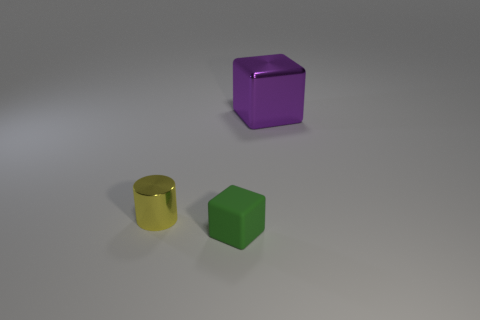There is a small green object that is the same shape as the big purple object; what material is it?
Your response must be concise. Rubber. Are there any other things that are the same size as the green block?
Ensure brevity in your answer.  Yes. Is the number of small yellow matte cylinders greater than the number of matte objects?
Provide a succinct answer. No. There is a thing that is behind the tiny matte thing and on the right side of the small yellow cylinder; what size is it?
Your answer should be very brief. Large. The big shiny object is what shape?
Make the answer very short. Cube. What number of metallic things have the same shape as the small green rubber object?
Your answer should be compact. 1. Is the number of small metal cylinders that are on the right side of the large metallic cube less than the number of shiny things right of the yellow metallic cylinder?
Offer a terse response. Yes. What number of shiny things are left of the object right of the tiny rubber object?
Give a very brief answer. 1. Are there any rubber spheres?
Make the answer very short. No. Are there any big blue objects made of the same material as the green object?
Offer a terse response. No. 